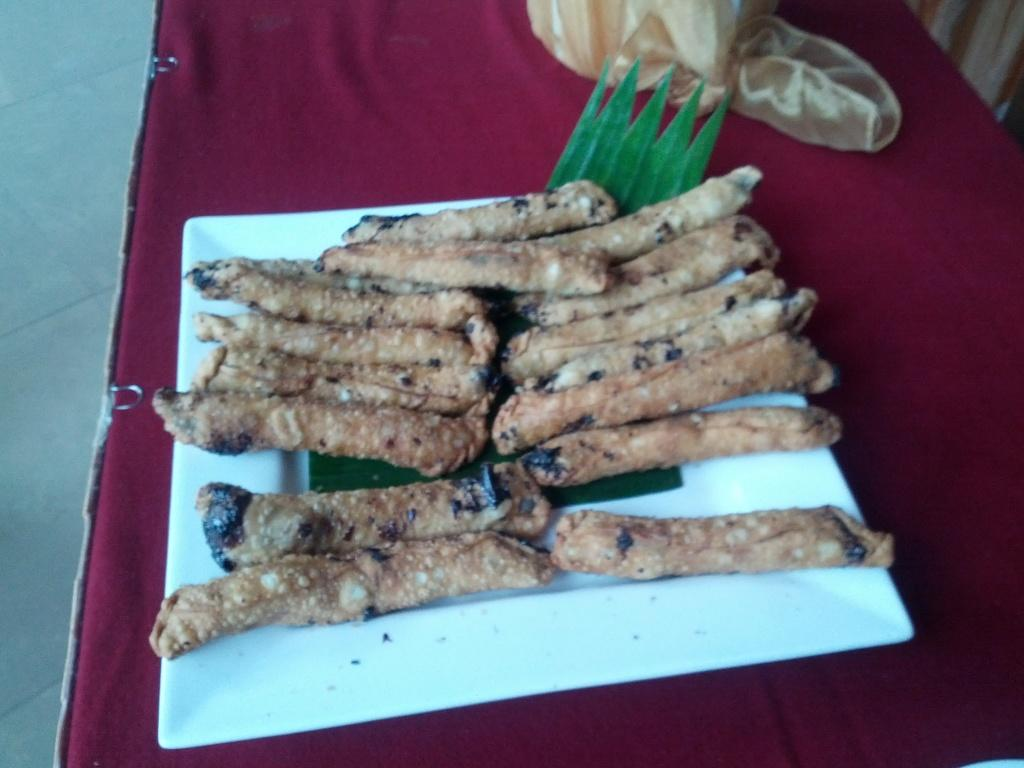What is on the plate in the image? There is food in the plate in the image. What color is the background of the image? The background color is red. Where is the sink located in the image? There is no sink present in the image. What process is being depicted in the image? The image does not depict a process; it shows a plate of food with a red background. 